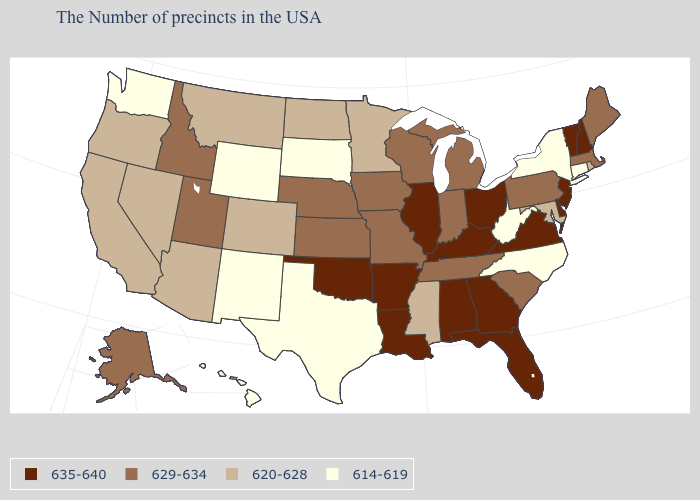Does Oklahoma have the highest value in the USA?
Quick response, please. Yes. Name the states that have a value in the range 620-628?
Give a very brief answer. Rhode Island, Maryland, Mississippi, Minnesota, North Dakota, Colorado, Montana, Arizona, Nevada, California, Oregon. How many symbols are there in the legend?
Keep it brief. 4. Which states have the lowest value in the West?
Keep it brief. Wyoming, New Mexico, Washington, Hawaii. Does the map have missing data?
Concise answer only. No. Name the states that have a value in the range 620-628?
Concise answer only. Rhode Island, Maryland, Mississippi, Minnesota, North Dakota, Colorado, Montana, Arizona, Nevada, California, Oregon. Which states have the lowest value in the USA?
Be succinct. Connecticut, New York, North Carolina, West Virginia, Texas, South Dakota, Wyoming, New Mexico, Washington, Hawaii. What is the value of Arkansas?
Answer briefly. 635-640. Name the states that have a value in the range 620-628?
Answer briefly. Rhode Island, Maryland, Mississippi, Minnesota, North Dakota, Colorado, Montana, Arizona, Nevada, California, Oregon. What is the highest value in states that border Indiana?
Keep it brief. 635-640. Among the states that border Wisconsin , does Iowa have the highest value?
Keep it brief. No. What is the lowest value in the USA?
Answer briefly. 614-619. Does Rhode Island have the lowest value in the Northeast?
Keep it brief. No. What is the value of New Jersey?
Write a very short answer. 635-640. Name the states that have a value in the range 620-628?
Answer briefly. Rhode Island, Maryland, Mississippi, Minnesota, North Dakota, Colorado, Montana, Arizona, Nevada, California, Oregon. 